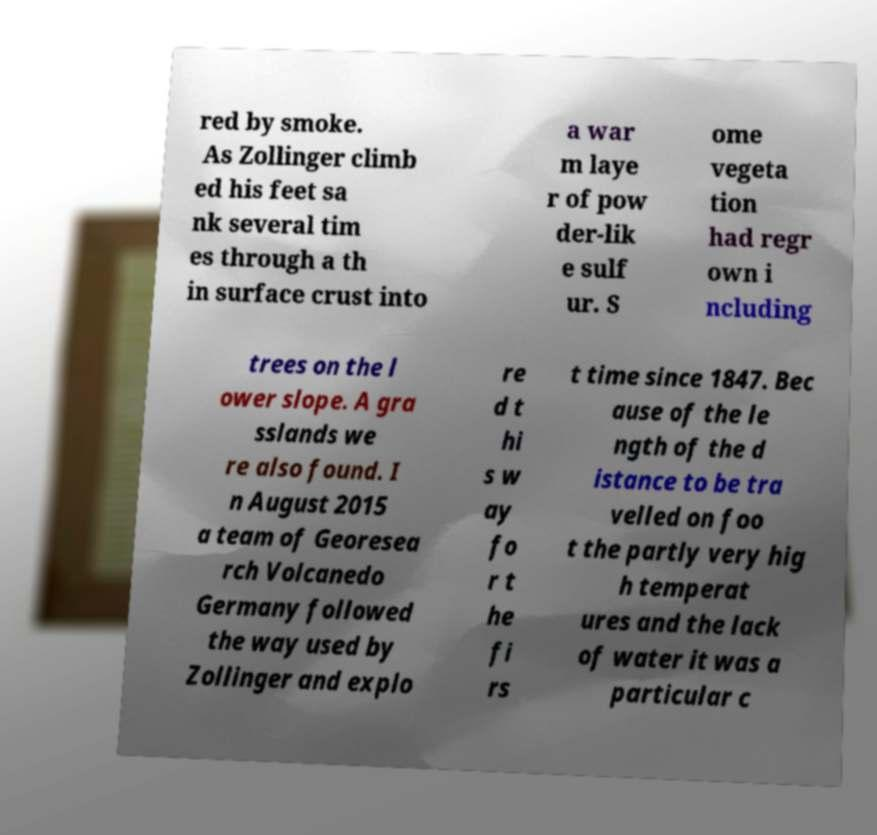Could you extract and type out the text from this image? red by smoke. As Zollinger climb ed his feet sa nk several tim es through a th in surface crust into a war m laye r of pow der-lik e sulf ur. S ome vegeta tion had regr own i ncluding trees on the l ower slope. A gra sslands we re also found. I n August 2015 a team of Georesea rch Volcanedo Germany followed the way used by Zollinger and explo re d t hi s w ay fo r t he fi rs t time since 1847. Bec ause of the le ngth of the d istance to be tra velled on foo t the partly very hig h temperat ures and the lack of water it was a particular c 